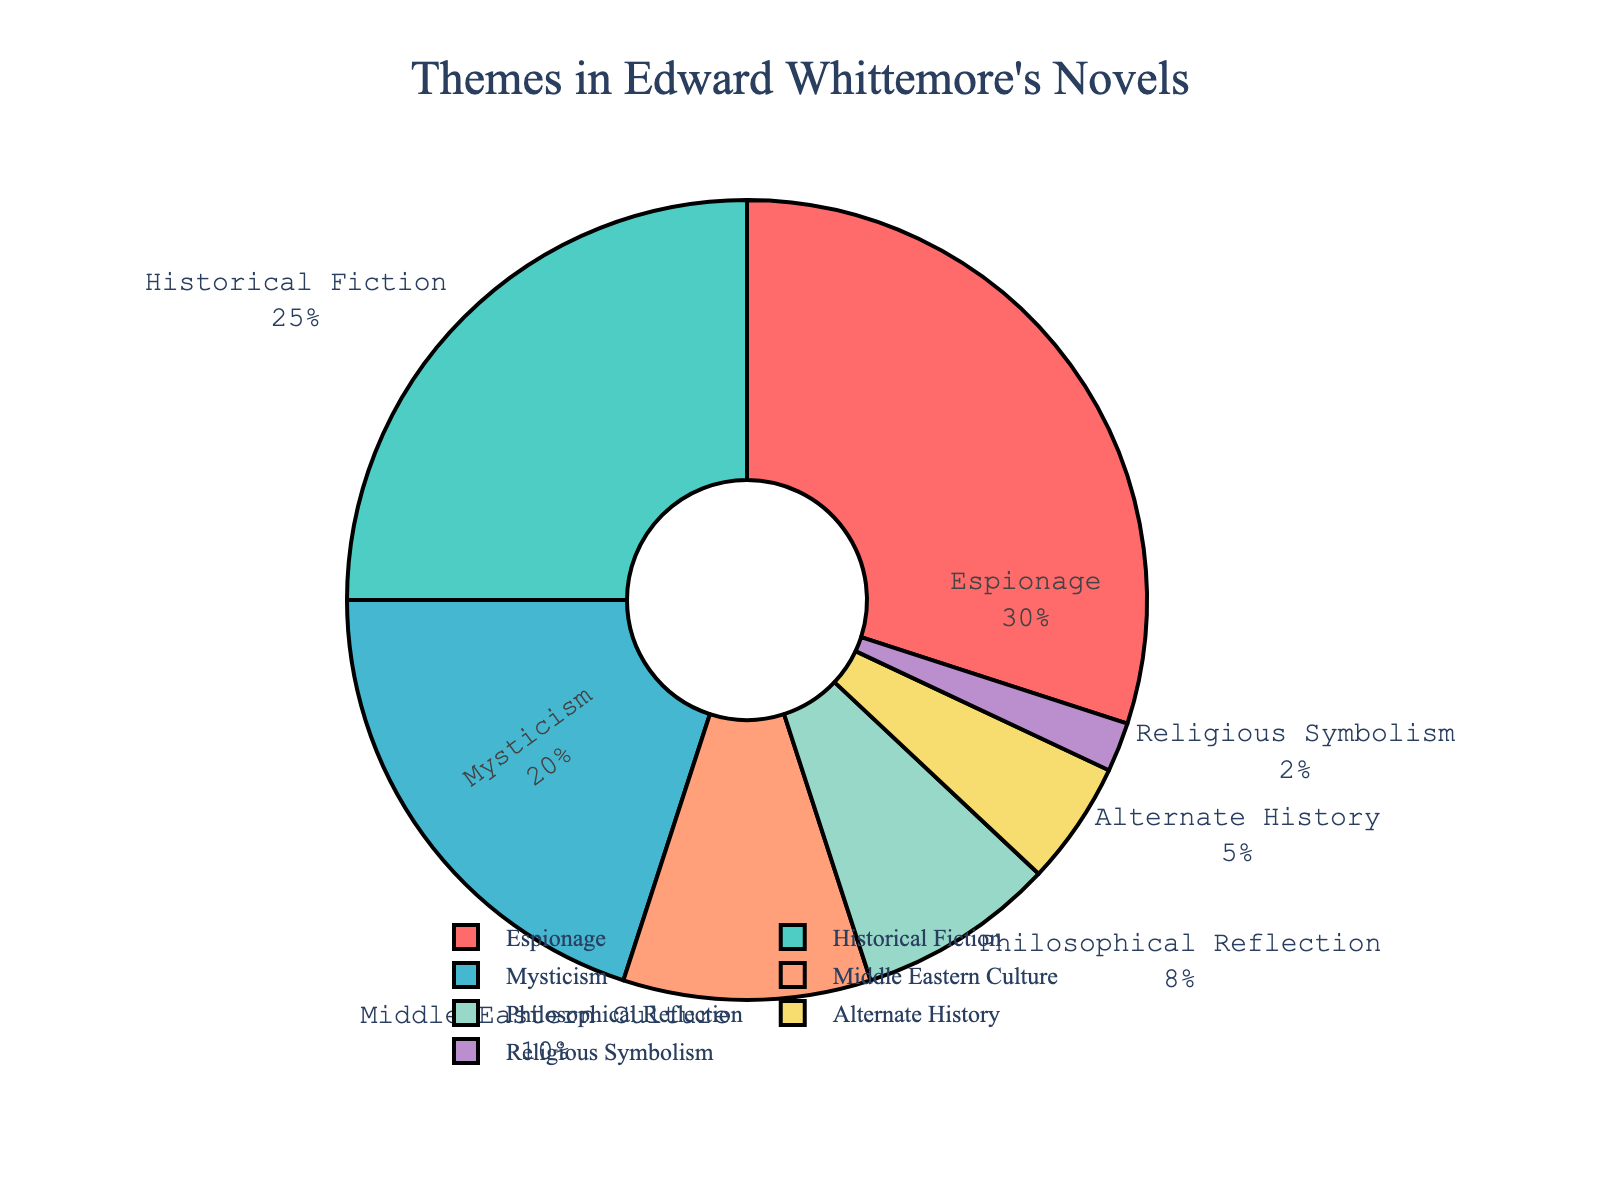Which theme in Edward Whittemore's novels has the highest percentage? The theme with the highest percentage can be identified by looking at the segment with the largest area on the pie chart. "Espionage" covers the largest area.
Answer: Espionage What is the combined percentage of Historical Fiction and Mysticism? To find the combined percentage, add the individual percentages of Historical Fiction (25%) and Mysticism (20%). 25% + 20% = 45%
Answer: 45% Which themes have a percentage less than 10%? By examining the pie chart, identify segments that represent less than 10%. These segments are Middle Eastern Culture (10%), Philosophical Reflection (8%), Alternate History (5%), and Religious Symbolism (2%).
Answer: Middle Eastern Culture, Philosophical Reflection, Alternate History, Religious Symbolism How does the percentage of Espionage compare with Historical Fiction and Mysticism combined? The percentage of Espionage is 30%. The combined percentage of Historical Fiction and Mysticism is 45%. 30% is less than 45%.
Answer: Less than What theme appears in the green-colored segment? The green color on the pie chart represents a specific theme; upon closer inspection, "Historical Fiction" is shown in green.
Answer: Historical Fiction Which theme has the smallest representation in the novels? By looking at the smallest segment of the pie chart, we can see that "Religious Symbolism" has the smallest percentage.
Answer: Religious Symbolism What is the difference in percentage between Espionage and Alternate History? To find the difference, subtract the percentage of Alternate History (5%) from the percentage of Espionage (30%). 30% - 5% = 25%
Answer: 25% Which themes together account for over half of the pie chart? Identifying themes with significant percentages: Espionage (30%), Historical Fiction (25%), and Mysticism (20%). Summing these gives 75%. 75% is more than half.
Answer: Espionage, Historical Fiction, Mysticism If we combine Middle Eastern Culture and Philosophical Reflection, what is their combined percentage? Add the percentages of Middle Eastern Culture (10%) and Philosophical Reflection (8%). 10% + 8% = 18%
Answer: 18% Which two themes have percentages that are closest to each other? By examining the pie chart, we see that Alternate History (5%) and Religious Symbolism (2%) have a small difference. The difference is 3%.
Answer: Alternate History, Religious Symbolism 